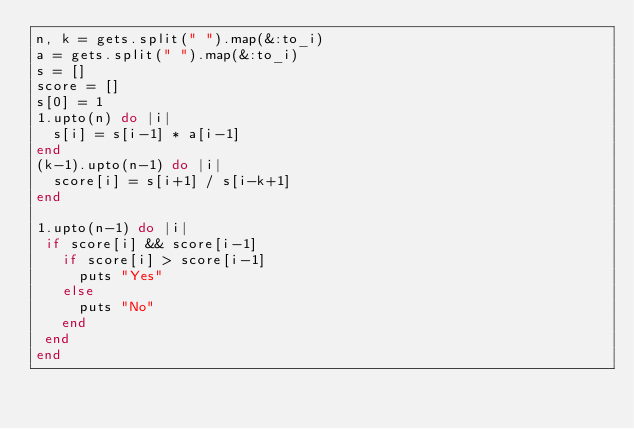Convert code to text. <code><loc_0><loc_0><loc_500><loc_500><_Ruby_>n, k = gets.split(" ").map(&:to_i)
a = gets.split(" ").map(&:to_i)
s = []
score = []
s[0] = 1
1.upto(n) do |i|
  s[i] = s[i-1] * a[i-1]
end
(k-1).upto(n-1) do |i|
  score[i] = s[i+1] / s[i-k+1]
end

1.upto(n-1) do |i|
 if score[i] && score[i-1]
   if score[i] > score[i-1]
     puts "Yes"
   else
     puts "No"
   end
 end
end</code> 